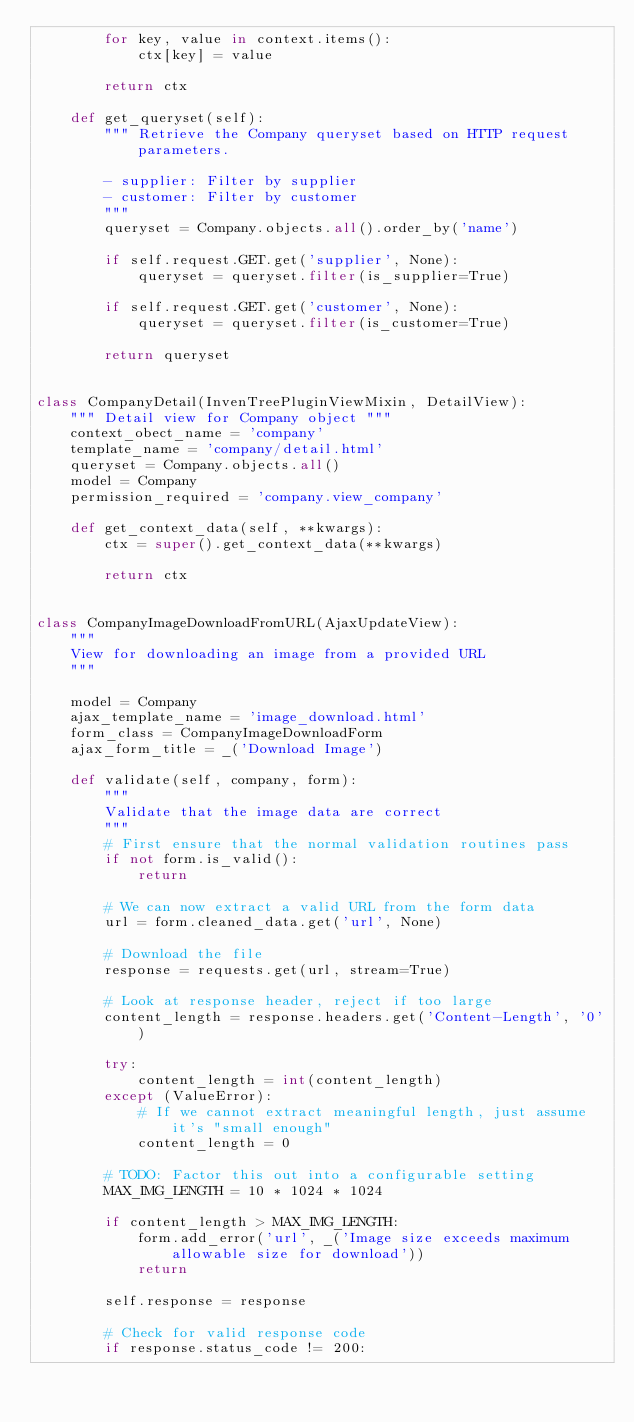Convert code to text. <code><loc_0><loc_0><loc_500><loc_500><_Python_>        for key, value in context.items():
            ctx[key] = value

        return ctx

    def get_queryset(self):
        """ Retrieve the Company queryset based on HTTP request parameters.

        - supplier: Filter by supplier
        - customer: Filter by customer
        """
        queryset = Company.objects.all().order_by('name')

        if self.request.GET.get('supplier', None):
            queryset = queryset.filter(is_supplier=True)

        if self.request.GET.get('customer', None):
            queryset = queryset.filter(is_customer=True)

        return queryset


class CompanyDetail(InvenTreePluginViewMixin, DetailView):
    """ Detail view for Company object """
    context_obect_name = 'company'
    template_name = 'company/detail.html'
    queryset = Company.objects.all()
    model = Company
    permission_required = 'company.view_company'

    def get_context_data(self, **kwargs):
        ctx = super().get_context_data(**kwargs)

        return ctx


class CompanyImageDownloadFromURL(AjaxUpdateView):
    """
    View for downloading an image from a provided URL
    """

    model = Company
    ajax_template_name = 'image_download.html'
    form_class = CompanyImageDownloadForm
    ajax_form_title = _('Download Image')

    def validate(self, company, form):
        """
        Validate that the image data are correct
        """
        # First ensure that the normal validation routines pass
        if not form.is_valid():
            return

        # We can now extract a valid URL from the form data
        url = form.cleaned_data.get('url', None)

        # Download the file
        response = requests.get(url, stream=True)

        # Look at response header, reject if too large
        content_length = response.headers.get('Content-Length', '0')

        try:
            content_length = int(content_length)
        except (ValueError):
            # If we cannot extract meaningful length, just assume it's "small enough"
            content_length = 0

        # TODO: Factor this out into a configurable setting
        MAX_IMG_LENGTH = 10 * 1024 * 1024

        if content_length > MAX_IMG_LENGTH:
            form.add_error('url', _('Image size exceeds maximum allowable size for download'))
            return

        self.response = response

        # Check for valid response code
        if response.status_code != 200:</code> 